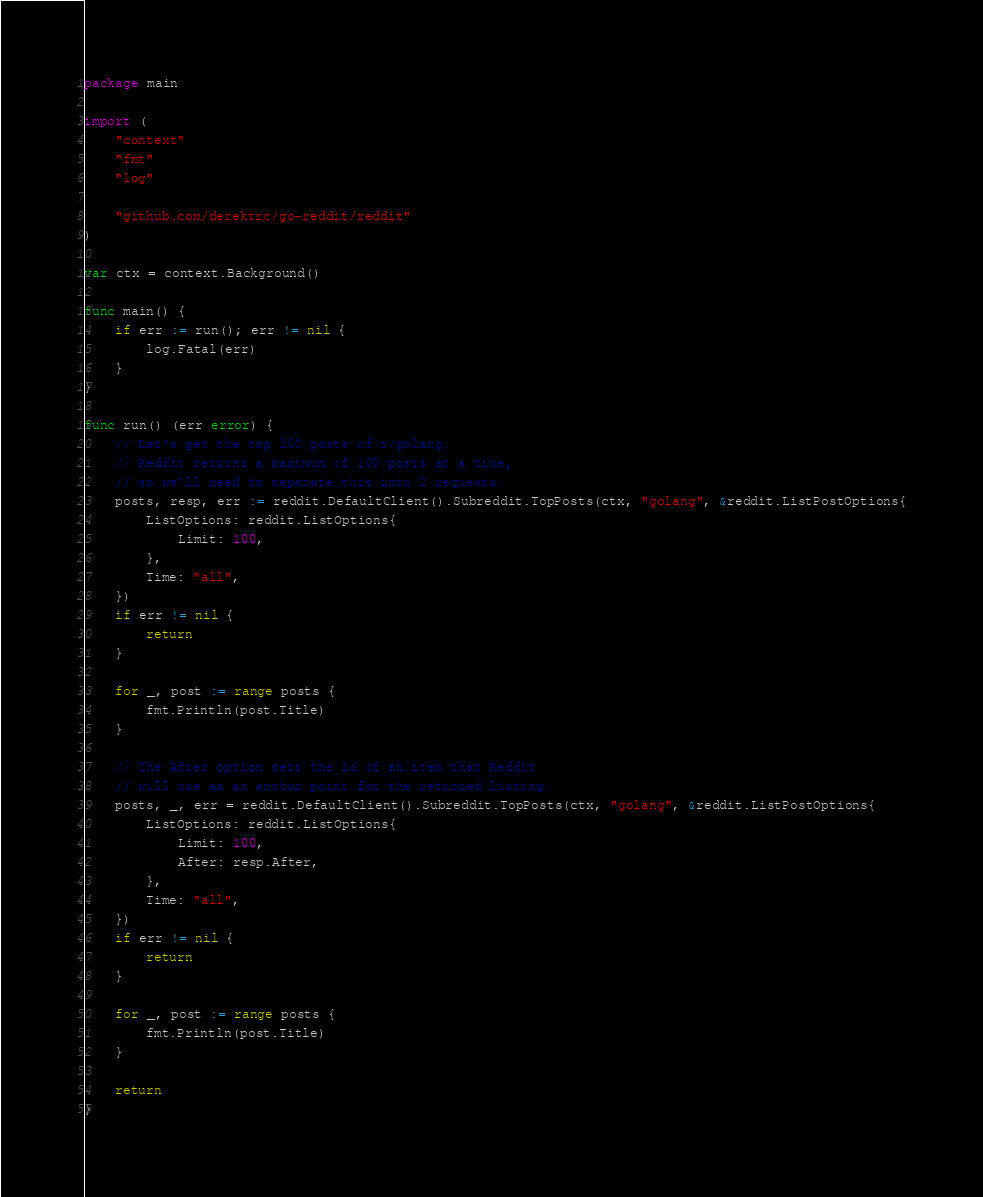<code> <loc_0><loc_0><loc_500><loc_500><_Go_>package main

import (
	"context"
	"fmt"
	"log"

	"github.com/derektrc/go-reddit/reddit"
)

var ctx = context.Background()

func main() {
	if err := run(); err != nil {
		log.Fatal(err)
	}
}

func run() (err error) {
	// Let's get the top 200 posts of r/golang.
	// Reddit returns a maximum of 100 posts at a time,
	// so we'll need to separate this into 2 requests.
	posts, resp, err := reddit.DefaultClient().Subreddit.TopPosts(ctx, "golang", &reddit.ListPostOptions{
		ListOptions: reddit.ListOptions{
			Limit: 100,
		},
		Time: "all",
	})
	if err != nil {
		return
	}

	for _, post := range posts {
		fmt.Println(post.Title)
	}

	// The After option sets the id of an item that Reddit
	// will use as an anchor point for the returned listing.
	posts, _, err = reddit.DefaultClient().Subreddit.TopPosts(ctx, "golang", &reddit.ListPostOptions{
		ListOptions: reddit.ListOptions{
			Limit: 100,
			After: resp.After,
		},
		Time: "all",
	})
	if err != nil {
		return
	}

	for _, post := range posts {
		fmt.Println(post.Title)
	}

	return
}
</code> 